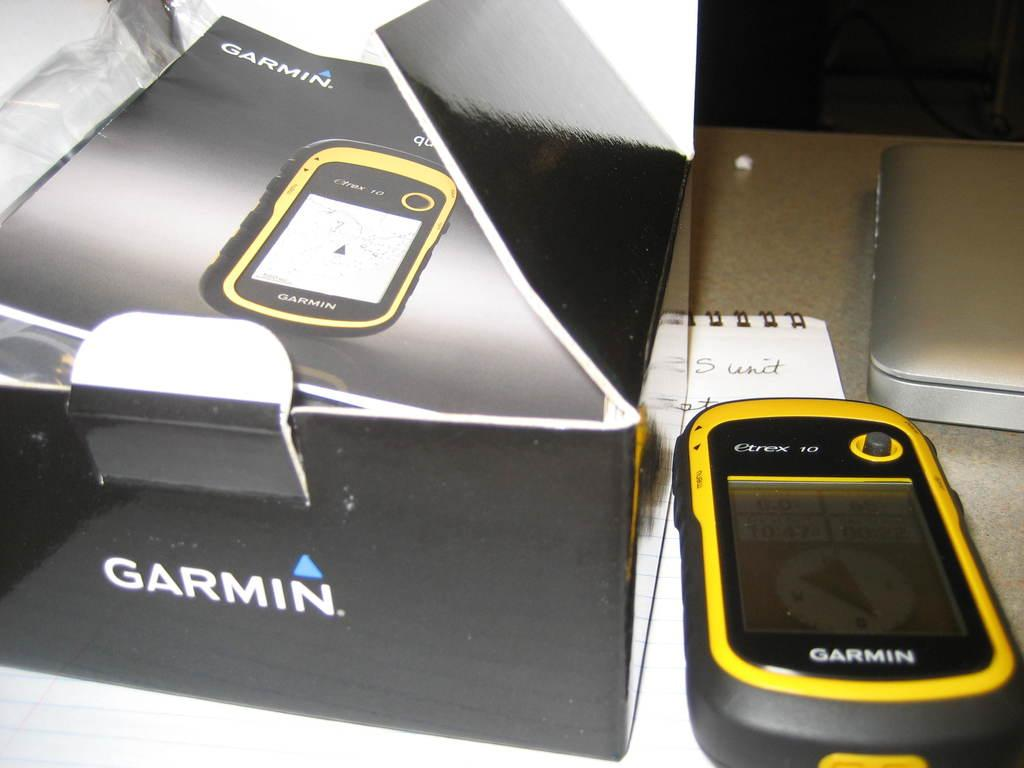<image>
Render a clear and concise summary of the photo. A Garmin device sits next to its box which has been opened. 